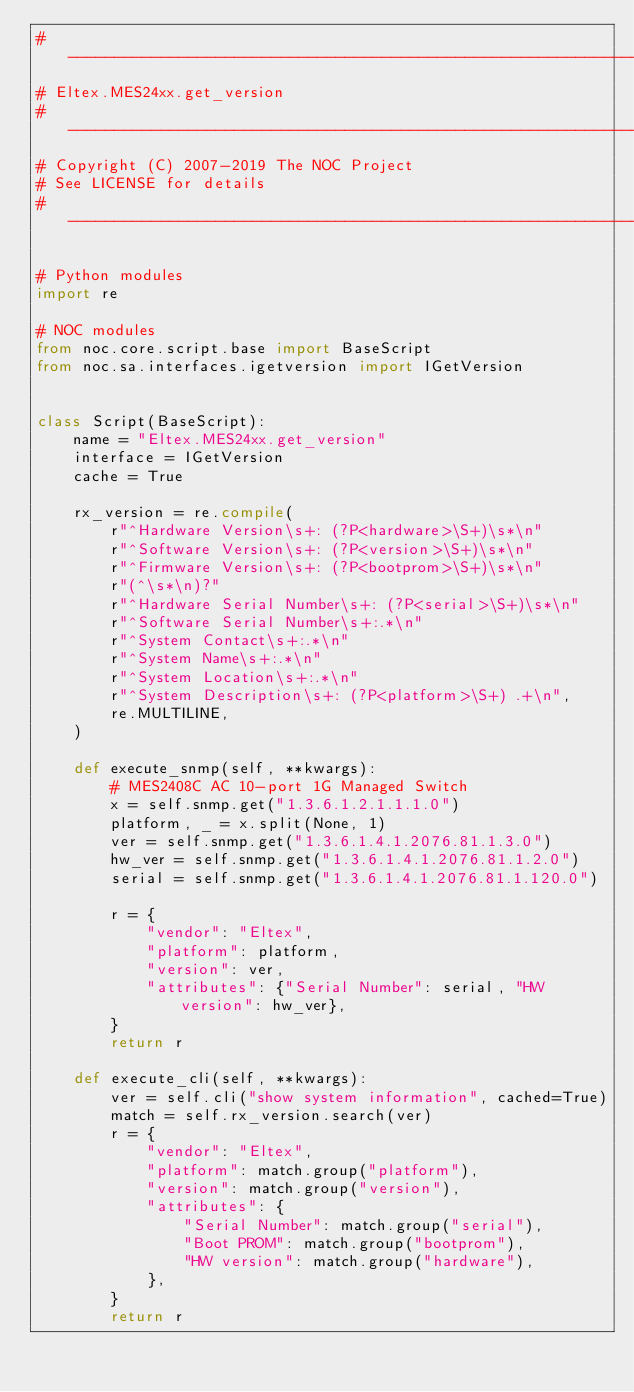<code> <loc_0><loc_0><loc_500><loc_500><_Python_># ---------------------------------------------------------------------
# Eltex.MES24xx.get_version
# ---------------------------------------------------------------------
# Copyright (C) 2007-2019 The NOC Project
# See LICENSE for details
# ---------------------------------------------------------------------

# Python modules
import re

# NOC modules
from noc.core.script.base import BaseScript
from noc.sa.interfaces.igetversion import IGetVersion


class Script(BaseScript):
    name = "Eltex.MES24xx.get_version"
    interface = IGetVersion
    cache = True

    rx_version = re.compile(
        r"^Hardware Version\s+: (?P<hardware>\S+)\s*\n"
        r"^Software Version\s+: (?P<version>\S+)\s*\n"
        r"^Firmware Version\s+: (?P<bootprom>\S+)\s*\n"
        r"(^\s*\n)?"
        r"^Hardware Serial Number\s+: (?P<serial>\S+)\s*\n"
        r"^Software Serial Number\s+:.*\n"
        r"^System Contact\s+:.*\n"
        r"^System Name\s+:.*\n"
        r"^System Location\s+:.*\n"
        r"^System Description\s+: (?P<platform>\S+) .+\n",
        re.MULTILINE,
    )

    def execute_snmp(self, **kwargs):
        # MES2408C AC 10-port 1G Managed Switch
        x = self.snmp.get("1.3.6.1.2.1.1.1.0")
        platform, _ = x.split(None, 1)
        ver = self.snmp.get("1.3.6.1.4.1.2076.81.1.3.0")
        hw_ver = self.snmp.get("1.3.6.1.4.1.2076.81.1.2.0")
        serial = self.snmp.get("1.3.6.1.4.1.2076.81.1.120.0")

        r = {
            "vendor": "Eltex",
            "platform": platform,
            "version": ver,
            "attributes": {"Serial Number": serial, "HW version": hw_ver},
        }
        return r

    def execute_cli(self, **kwargs):
        ver = self.cli("show system information", cached=True)
        match = self.rx_version.search(ver)
        r = {
            "vendor": "Eltex",
            "platform": match.group("platform"),
            "version": match.group("version"),
            "attributes": {
                "Serial Number": match.group("serial"),
                "Boot PROM": match.group("bootprom"),
                "HW version": match.group("hardware"),
            },
        }
        return r
</code> 